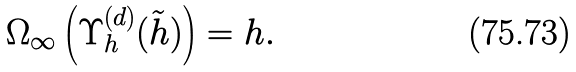<formula> <loc_0><loc_0><loc_500><loc_500>\Omega _ { \infty } \left ( \Upsilon _ { h } ^ { ( d ) } ( \tilde { h } ) \right ) = h .</formula> 